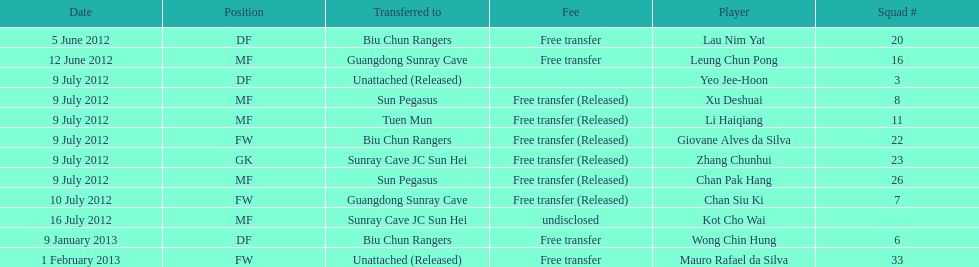Player transferred immediately before mauro rafael da silva Wong Chin Hung. 